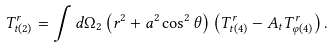<formula> <loc_0><loc_0><loc_500><loc_500>T _ { t ( 2 ) } ^ { r } = \int d \Omega _ { 2 } \left ( r ^ { 2 } + a ^ { 2 } \cos ^ { 2 } \theta \right ) \left ( T _ { t ( 4 ) } ^ { r } - A _ { t } T ^ { r } _ { \varphi ( 4 ) } \right ) .</formula> 